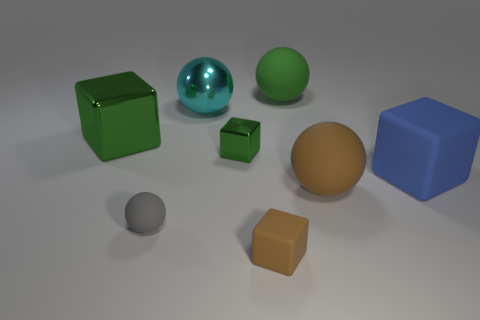How many things are cyan shiny things or things in front of the tiny gray ball?
Make the answer very short. 2. Are there fewer large spheres than small green blocks?
Your answer should be very brief. No. Is the number of large blue cubes greater than the number of big rubber balls?
Your answer should be compact. No. How many other things are there of the same material as the large brown thing?
Your answer should be compact. 4. There is a thing that is on the left side of the tiny gray thing left of the large rubber cube; what number of big rubber spheres are in front of it?
Make the answer very short. 1. What number of rubber things are brown objects or gray things?
Your response must be concise. 3. There is a matte sphere behind the rubber block to the right of the small brown block; how big is it?
Keep it short and to the point. Large. There is a ball that is right of the green rubber object; is its color the same as the block in front of the blue matte object?
Your answer should be compact. Yes. The thing that is both behind the big green metal cube and right of the large shiny ball is what color?
Your response must be concise. Green. Is the material of the brown sphere the same as the blue block?
Offer a terse response. Yes. 